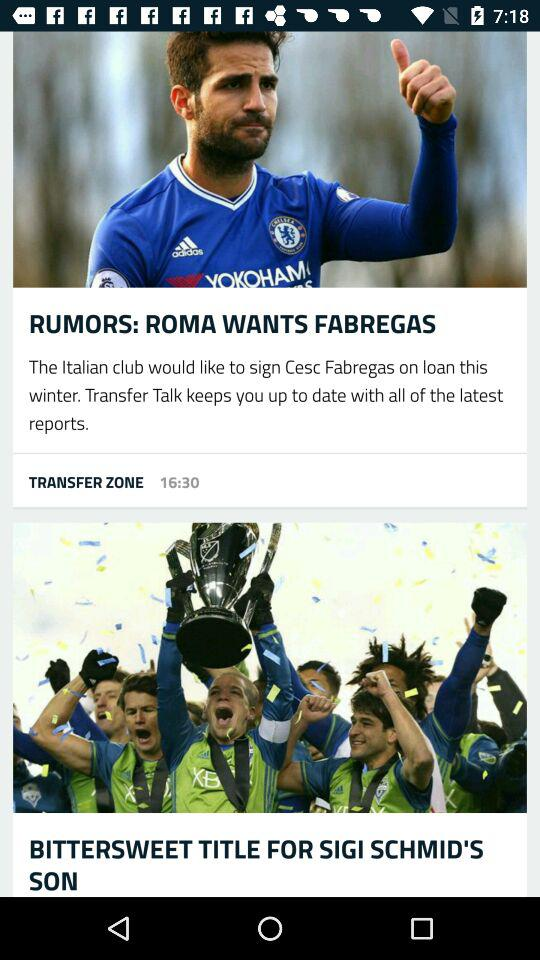At what time was the article posted by "TRANSFER ZONE"? The article was posted by "TRANSFER ZONE" at 16:30. 